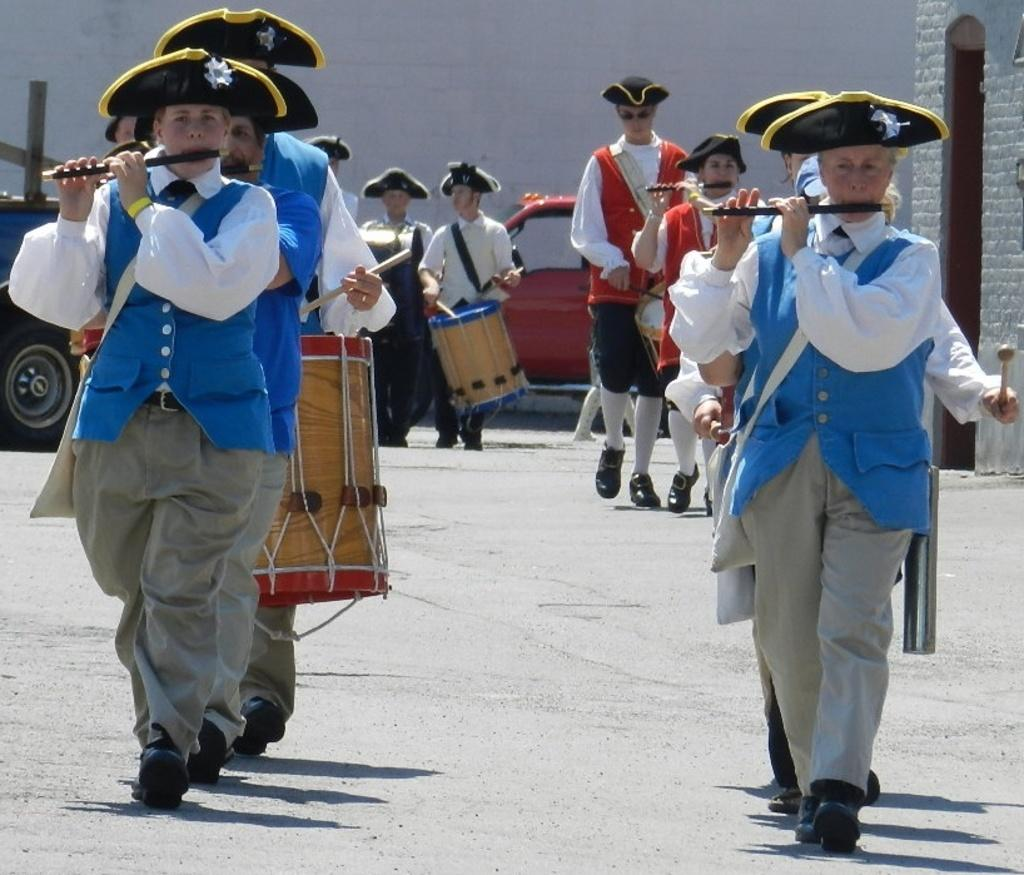What are the people in the image doing? The people in the image are standing on the road. What instruments are some of the people holding? Some people are holding flutes and drums. Is there any vehicle visible in the image? Yes, there is a car parked on the road. Can you see any islands in the image? No, there are no islands visible in the image. What type of quilt is being used to cover the car in the image? There is no quilt present in the image, and the car is not covered. 